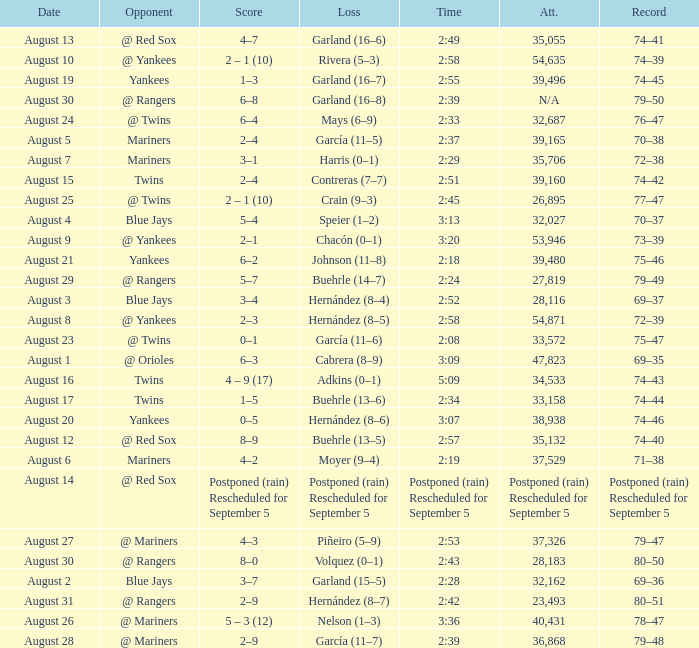Who lost on August 27? Piñeiro (5–9). 